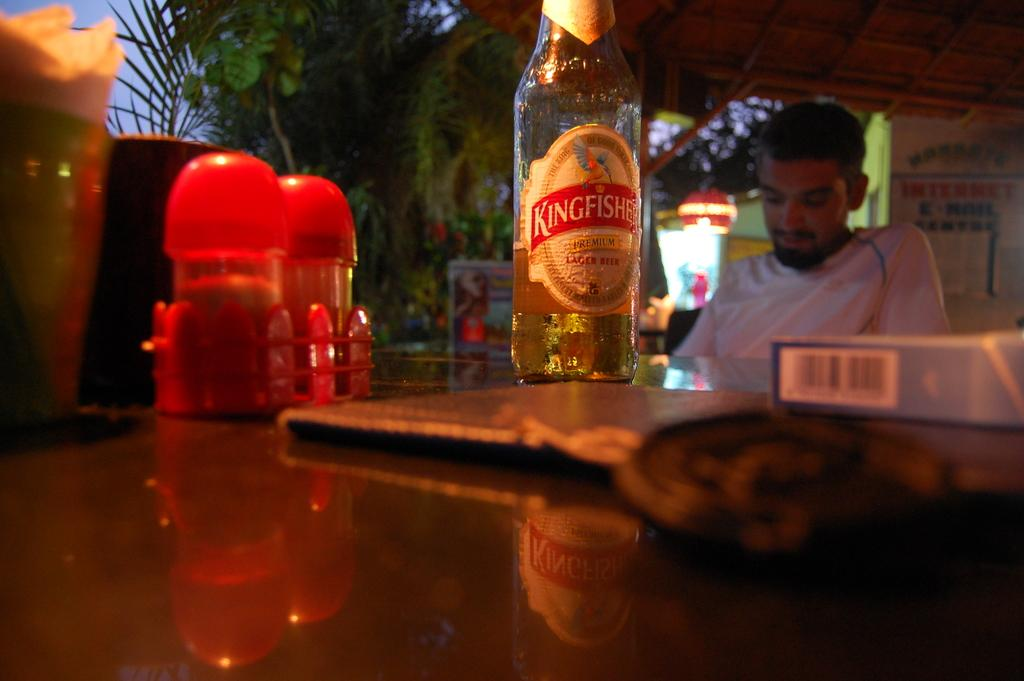What is the man in the image doing? The man is sitting at a table. What can be seen on the table in the image? There is a beer bottle, salt and pepper containers, and a book on the table. What type of disease can be seen affecting the man's eyes in the image? There is no indication of any disease affecting the man's eyes in the image. 